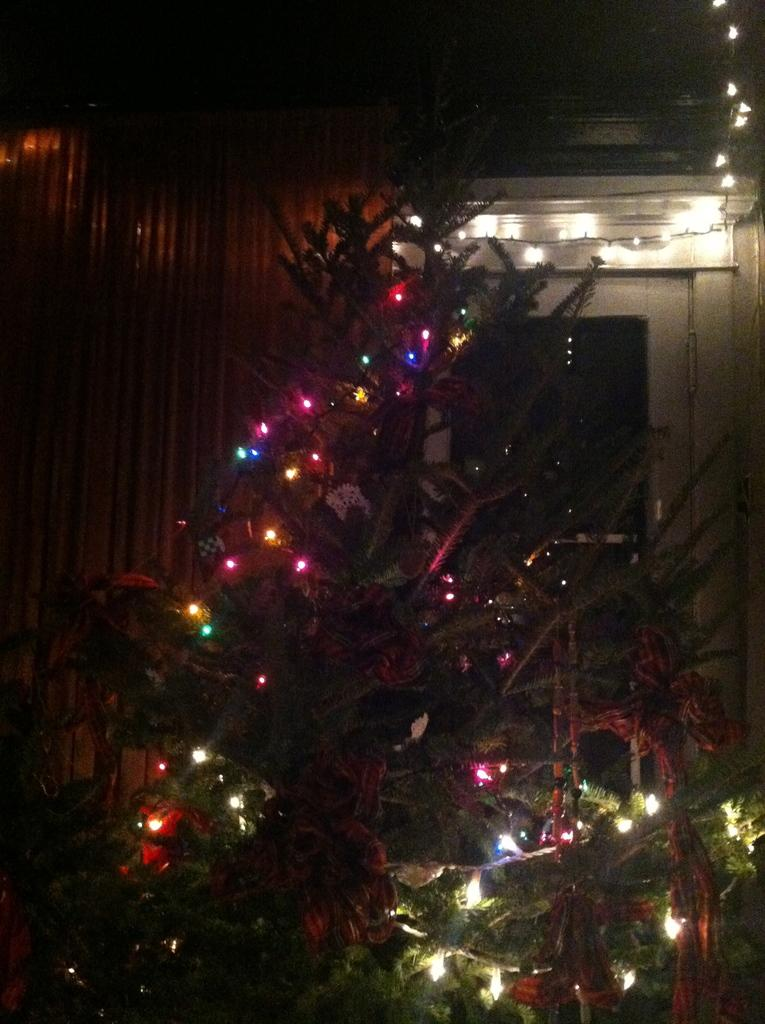What is the main feature of the tree in the image? There are decorative lights on the tree. How would you describe the overall lighting in the image? The background of the image is dark. Can you describe any other objects visible in the background? There are other objects visible in the background, but their specific details are not mentioned in the facts. What type of structure can be seen in the background? There is a wall in the background of the image. How many passengers are waiting for the system to arrive in the image? There is no reference to a system or passengers in the image; it features a tree with decorative lights and a dark background. 